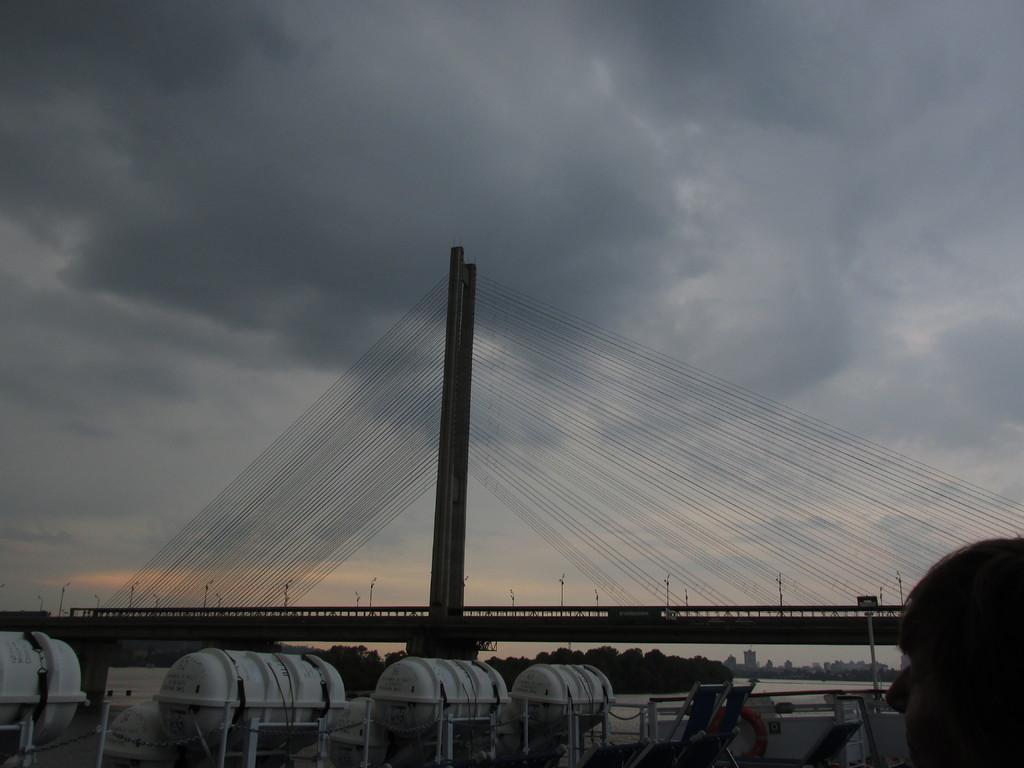How would you summarize this image in a sentence or two? At the bottom of the image there are white color tanks. There is a person. In the center of the image there is a bridge with ropes. At the top of the image there is sky and clouds. In the background of the image there are trees and buildings. 